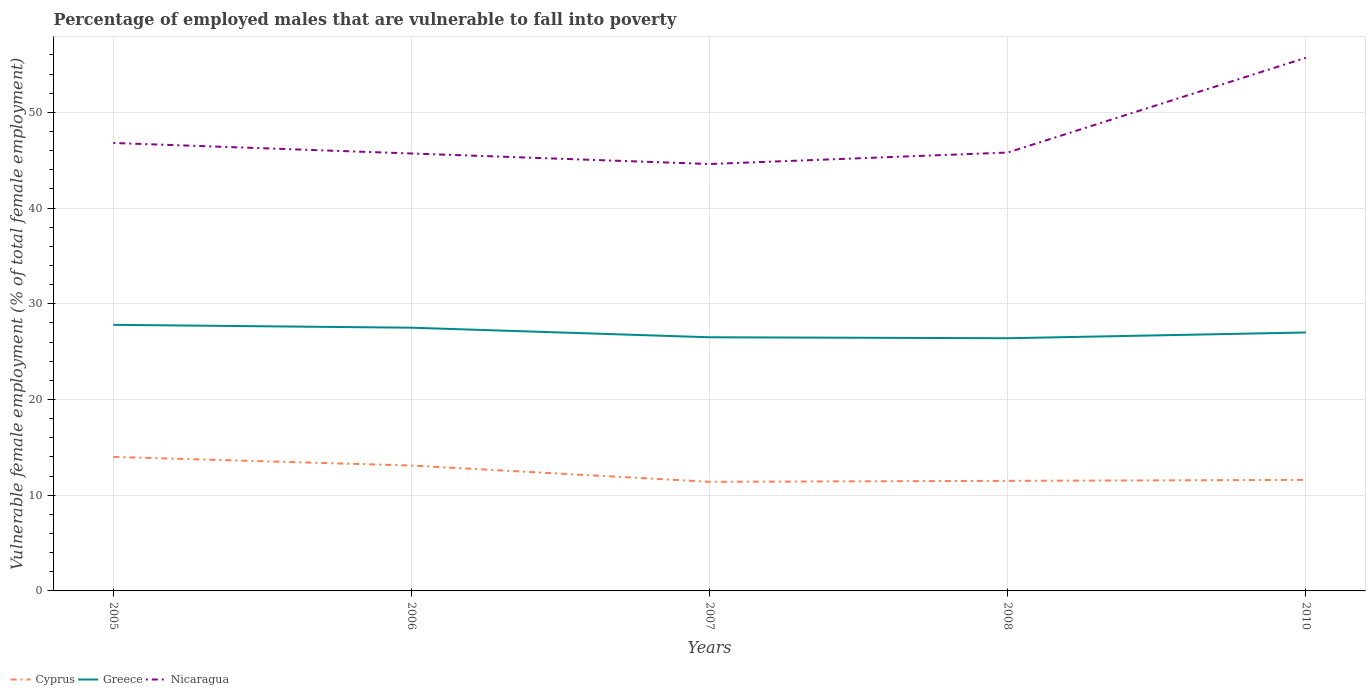How many different coloured lines are there?
Keep it short and to the point. 3. Does the line corresponding to Cyprus intersect with the line corresponding to Nicaragua?
Provide a short and direct response. No. Across all years, what is the maximum percentage of employed males who are vulnerable to fall into poverty in Nicaragua?
Offer a very short reply. 44.6. What is the total percentage of employed males who are vulnerable to fall into poverty in Nicaragua in the graph?
Your answer should be compact. -1.2. What is the difference between the highest and the second highest percentage of employed males who are vulnerable to fall into poverty in Nicaragua?
Give a very brief answer. 11.1. What is the difference between the highest and the lowest percentage of employed males who are vulnerable to fall into poverty in Greece?
Give a very brief answer. 2. How many lines are there?
Offer a very short reply. 3. Does the graph contain grids?
Offer a very short reply. Yes. Where does the legend appear in the graph?
Keep it short and to the point. Bottom left. How many legend labels are there?
Your response must be concise. 3. How are the legend labels stacked?
Give a very brief answer. Horizontal. What is the title of the graph?
Offer a terse response. Percentage of employed males that are vulnerable to fall into poverty. Does "Costa Rica" appear as one of the legend labels in the graph?
Offer a terse response. No. What is the label or title of the X-axis?
Your answer should be very brief. Years. What is the label or title of the Y-axis?
Make the answer very short. Vulnerable female employment (% of total female employment). What is the Vulnerable female employment (% of total female employment) of Greece in 2005?
Make the answer very short. 27.8. What is the Vulnerable female employment (% of total female employment) in Nicaragua in 2005?
Your answer should be very brief. 46.8. What is the Vulnerable female employment (% of total female employment) in Cyprus in 2006?
Offer a terse response. 13.1. What is the Vulnerable female employment (% of total female employment) in Nicaragua in 2006?
Your response must be concise. 45.7. What is the Vulnerable female employment (% of total female employment) of Cyprus in 2007?
Your response must be concise. 11.4. What is the Vulnerable female employment (% of total female employment) of Greece in 2007?
Your answer should be compact. 26.5. What is the Vulnerable female employment (% of total female employment) in Nicaragua in 2007?
Provide a short and direct response. 44.6. What is the Vulnerable female employment (% of total female employment) in Greece in 2008?
Offer a terse response. 26.4. What is the Vulnerable female employment (% of total female employment) in Nicaragua in 2008?
Your answer should be very brief. 45.8. What is the Vulnerable female employment (% of total female employment) of Cyprus in 2010?
Make the answer very short. 11.6. What is the Vulnerable female employment (% of total female employment) of Nicaragua in 2010?
Your response must be concise. 55.7. Across all years, what is the maximum Vulnerable female employment (% of total female employment) of Cyprus?
Provide a short and direct response. 14. Across all years, what is the maximum Vulnerable female employment (% of total female employment) of Greece?
Your answer should be compact. 27.8. Across all years, what is the maximum Vulnerable female employment (% of total female employment) of Nicaragua?
Make the answer very short. 55.7. Across all years, what is the minimum Vulnerable female employment (% of total female employment) in Cyprus?
Your answer should be very brief. 11.4. Across all years, what is the minimum Vulnerable female employment (% of total female employment) in Greece?
Keep it short and to the point. 26.4. Across all years, what is the minimum Vulnerable female employment (% of total female employment) of Nicaragua?
Offer a very short reply. 44.6. What is the total Vulnerable female employment (% of total female employment) of Cyprus in the graph?
Your response must be concise. 61.6. What is the total Vulnerable female employment (% of total female employment) in Greece in the graph?
Keep it short and to the point. 135.2. What is the total Vulnerable female employment (% of total female employment) in Nicaragua in the graph?
Offer a very short reply. 238.6. What is the difference between the Vulnerable female employment (% of total female employment) of Cyprus in 2005 and that in 2006?
Ensure brevity in your answer.  0.9. What is the difference between the Vulnerable female employment (% of total female employment) in Greece in 2005 and that in 2006?
Offer a very short reply. 0.3. What is the difference between the Vulnerable female employment (% of total female employment) of Nicaragua in 2005 and that in 2006?
Your answer should be compact. 1.1. What is the difference between the Vulnerable female employment (% of total female employment) in Greece in 2005 and that in 2007?
Provide a short and direct response. 1.3. What is the difference between the Vulnerable female employment (% of total female employment) of Nicaragua in 2005 and that in 2007?
Offer a terse response. 2.2. What is the difference between the Vulnerable female employment (% of total female employment) in Cyprus in 2005 and that in 2010?
Give a very brief answer. 2.4. What is the difference between the Vulnerable female employment (% of total female employment) in Greece in 2005 and that in 2010?
Provide a succinct answer. 0.8. What is the difference between the Vulnerable female employment (% of total female employment) in Cyprus in 2006 and that in 2007?
Provide a succinct answer. 1.7. What is the difference between the Vulnerable female employment (% of total female employment) in Greece in 2006 and that in 2008?
Ensure brevity in your answer.  1.1. What is the difference between the Vulnerable female employment (% of total female employment) in Cyprus in 2006 and that in 2010?
Offer a terse response. 1.5. What is the difference between the Vulnerable female employment (% of total female employment) in Nicaragua in 2006 and that in 2010?
Offer a terse response. -10. What is the difference between the Vulnerable female employment (% of total female employment) of Nicaragua in 2008 and that in 2010?
Offer a terse response. -9.9. What is the difference between the Vulnerable female employment (% of total female employment) in Cyprus in 2005 and the Vulnerable female employment (% of total female employment) in Nicaragua in 2006?
Give a very brief answer. -31.7. What is the difference between the Vulnerable female employment (% of total female employment) of Greece in 2005 and the Vulnerable female employment (% of total female employment) of Nicaragua in 2006?
Offer a terse response. -17.9. What is the difference between the Vulnerable female employment (% of total female employment) in Cyprus in 2005 and the Vulnerable female employment (% of total female employment) in Greece in 2007?
Provide a short and direct response. -12.5. What is the difference between the Vulnerable female employment (% of total female employment) in Cyprus in 2005 and the Vulnerable female employment (% of total female employment) in Nicaragua in 2007?
Your response must be concise. -30.6. What is the difference between the Vulnerable female employment (% of total female employment) of Greece in 2005 and the Vulnerable female employment (% of total female employment) of Nicaragua in 2007?
Give a very brief answer. -16.8. What is the difference between the Vulnerable female employment (% of total female employment) in Cyprus in 2005 and the Vulnerable female employment (% of total female employment) in Nicaragua in 2008?
Provide a short and direct response. -31.8. What is the difference between the Vulnerable female employment (% of total female employment) in Greece in 2005 and the Vulnerable female employment (% of total female employment) in Nicaragua in 2008?
Your response must be concise. -18. What is the difference between the Vulnerable female employment (% of total female employment) of Cyprus in 2005 and the Vulnerable female employment (% of total female employment) of Nicaragua in 2010?
Offer a terse response. -41.7. What is the difference between the Vulnerable female employment (% of total female employment) in Greece in 2005 and the Vulnerable female employment (% of total female employment) in Nicaragua in 2010?
Offer a very short reply. -27.9. What is the difference between the Vulnerable female employment (% of total female employment) of Cyprus in 2006 and the Vulnerable female employment (% of total female employment) of Nicaragua in 2007?
Provide a succinct answer. -31.5. What is the difference between the Vulnerable female employment (% of total female employment) in Greece in 2006 and the Vulnerable female employment (% of total female employment) in Nicaragua in 2007?
Your response must be concise. -17.1. What is the difference between the Vulnerable female employment (% of total female employment) in Cyprus in 2006 and the Vulnerable female employment (% of total female employment) in Greece in 2008?
Provide a short and direct response. -13.3. What is the difference between the Vulnerable female employment (% of total female employment) in Cyprus in 2006 and the Vulnerable female employment (% of total female employment) in Nicaragua in 2008?
Provide a short and direct response. -32.7. What is the difference between the Vulnerable female employment (% of total female employment) of Greece in 2006 and the Vulnerable female employment (% of total female employment) of Nicaragua in 2008?
Make the answer very short. -18.3. What is the difference between the Vulnerable female employment (% of total female employment) in Cyprus in 2006 and the Vulnerable female employment (% of total female employment) in Nicaragua in 2010?
Offer a very short reply. -42.6. What is the difference between the Vulnerable female employment (% of total female employment) in Greece in 2006 and the Vulnerable female employment (% of total female employment) in Nicaragua in 2010?
Offer a terse response. -28.2. What is the difference between the Vulnerable female employment (% of total female employment) in Cyprus in 2007 and the Vulnerable female employment (% of total female employment) in Greece in 2008?
Your answer should be very brief. -15. What is the difference between the Vulnerable female employment (% of total female employment) of Cyprus in 2007 and the Vulnerable female employment (% of total female employment) of Nicaragua in 2008?
Make the answer very short. -34.4. What is the difference between the Vulnerable female employment (% of total female employment) in Greece in 2007 and the Vulnerable female employment (% of total female employment) in Nicaragua in 2008?
Ensure brevity in your answer.  -19.3. What is the difference between the Vulnerable female employment (% of total female employment) in Cyprus in 2007 and the Vulnerable female employment (% of total female employment) in Greece in 2010?
Your response must be concise. -15.6. What is the difference between the Vulnerable female employment (% of total female employment) of Cyprus in 2007 and the Vulnerable female employment (% of total female employment) of Nicaragua in 2010?
Offer a very short reply. -44.3. What is the difference between the Vulnerable female employment (% of total female employment) of Greece in 2007 and the Vulnerable female employment (% of total female employment) of Nicaragua in 2010?
Offer a terse response. -29.2. What is the difference between the Vulnerable female employment (% of total female employment) of Cyprus in 2008 and the Vulnerable female employment (% of total female employment) of Greece in 2010?
Your answer should be very brief. -15.5. What is the difference between the Vulnerable female employment (% of total female employment) of Cyprus in 2008 and the Vulnerable female employment (% of total female employment) of Nicaragua in 2010?
Your answer should be compact. -44.2. What is the difference between the Vulnerable female employment (% of total female employment) of Greece in 2008 and the Vulnerable female employment (% of total female employment) of Nicaragua in 2010?
Your response must be concise. -29.3. What is the average Vulnerable female employment (% of total female employment) in Cyprus per year?
Give a very brief answer. 12.32. What is the average Vulnerable female employment (% of total female employment) of Greece per year?
Keep it short and to the point. 27.04. What is the average Vulnerable female employment (% of total female employment) of Nicaragua per year?
Offer a very short reply. 47.72. In the year 2005, what is the difference between the Vulnerable female employment (% of total female employment) of Cyprus and Vulnerable female employment (% of total female employment) of Nicaragua?
Your response must be concise. -32.8. In the year 2005, what is the difference between the Vulnerable female employment (% of total female employment) of Greece and Vulnerable female employment (% of total female employment) of Nicaragua?
Ensure brevity in your answer.  -19. In the year 2006, what is the difference between the Vulnerable female employment (% of total female employment) of Cyprus and Vulnerable female employment (% of total female employment) of Greece?
Give a very brief answer. -14.4. In the year 2006, what is the difference between the Vulnerable female employment (% of total female employment) of Cyprus and Vulnerable female employment (% of total female employment) of Nicaragua?
Offer a terse response. -32.6. In the year 2006, what is the difference between the Vulnerable female employment (% of total female employment) of Greece and Vulnerable female employment (% of total female employment) of Nicaragua?
Offer a terse response. -18.2. In the year 2007, what is the difference between the Vulnerable female employment (% of total female employment) of Cyprus and Vulnerable female employment (% of total female employment) of Greece?
Give a very brief answer. -15.1. In the year 2007, what is the difference between the Vulnerable female employment (% of total female employment) of Cyprus and Vulnerable female employment (% of total female employment) of Nicaragua?
Your answer should be compact. -33.2. In the year 2007, what is the difference between the Vulnerable female employment (% of total female employment) of Greece and Vulnerable female employment (% of total female employment) of Nicaragua?
Your response must be concise. -18.1. In the year 2008, what is the difference between the Vulnerable female employment (% of total female employment) in Cyprus and Vulnerable female employment (% of total female employment) in Greece?
Keep it short and to the point. -14.9. In the year 2008, what is the difference between the Vulnerable female employment (% of total female employment) of Cyprus and Vulnerable female employment (% of total female employment) of Nicaragua?
Ensure brevity in your answer.  -34.3. In the year 2008, what is the difference between the Vulnerable female employment (% of total female employment) in Greece and Vulnerable female employment (% of total female employment) in Nicaragua?
Your answer should be compact. -19.4. In the year 2010, what is the difference between the Vulnerable female employment (% of total female employment) in Cyprus and Vulnerable female employment (% of total female employment) in Greece?
Offer a terse response. -15.4. In the year 2010, what is the difference between the Vulnerable female employment (% of total female employment) of Cyprus and Vulnerable female employment (% of total female employment) of Nicaragua?
Your answer should be very brief. -44.1. In the year 2010, what is the difference between the Vulnerable female employment (% of total female employment) of Greece and Vulnerable female employment (% of total female employment) of Nicaragua?
Your answer should be compact. -28.7. What is the ratio of the Vulnerable female employment (% of total female employment) of Cyprus in 2005 to that in 2006?
Offer a terse response. 1.07. What is the ratio of the Vulnerable female employment (% of total female employment) of Greece in 2005 to that in 2006?
Your answer should be compact. 1.01. What is the ratio of the Vulnerable female employment (% of total female employment) of Nicaragua in 2005 to that in 2006?
Offer a terse response. 1.02. What is the ratio of the Vulnerable female employment (% of total female employment) in Cyprus in 2005 to that in 2007?
Ensure brevity in your answer.  1.23. What is the ratio of the Vulnerable female employment (% of total female employment) in Greece in 2005 to that in 2007?
Provide a succinct answer. 1.05. What is the ratio of the Vulnerable female employment (% of total female employment) of Nicaragua in 2005 to that in 2007?
Make the answer very short. 1.05. What is the ratio of the Vulnerable female employment (% of total female employment) in Cyprus in 2005 to that in 2008?
Make the answer very short. 1.22. What is the ratio of the Vulnerable female employment (% of total female employment) of Greece in 2005 to that in 2008?
Provide a short and direct response. 1.05. What is the ratio of the Vulnerable female employment (% of total female employment) of Nicaragua in 2005 to that in 2008?
Provide a short and direct response. 1.02. What is the ratio of the Vulnerable female employment (% of total female employment) of Cyprus in 2005 to that in 2010?
Offer a terse response. 1.21. What is the ratio of the Vulnerable female employment (% of total female employment) in Greece in 2005 to that in 2010?
Provide a succinct answer. 1.03. What is the ratio of the Vulnerable female employment (% of total female employment) of Nicaragua in 2005 to that in 2010?
Provide a succinct answer. 0.84. What is the ratio of the Vulnerable female employment (% of total female employment) in Cyprus in 2006 to that in 2007?
Make the answer very short. 1.15. What is the ratio of the Vulnerable female employment (% of total female employment) in Greece in 2006 to that in 2007?
Make the answer very short. 1.04. What is the ratio of the Vulnerable female employment (% of total female employment) in Nicaragua in 2006 to that in 2007?
Provide a succinct answer. 1.02. What is the ratio of the Vulnerable female employment (% of total female employment) of Cyprus in 2006 to that in 2008?
Offer a very short reply. 1.14. What is the ratio of the Vulnerable female employment (% of total female employment) of Greece in 2006 to that in 2008?
Your response must be concise. 1.04. What is the ratio of the Vulnerable female employment (% of total female employment) of Nicaragua in 2006 to that in 2008?
Provide a succinct answer. 1. What is the ratio of the Vulnerable female employment (% of total female employment) in Cyprus in 2006 to that in 2010?
Keep it short and to the point. 1.13. What is the ratio of the Vulnerable female employment (% of total female employment) in Greece in 2006 to that in 2010?
Ensure brevity in your answer.  1.02. What is the ratio of the Vulnerable female employment (% of total female employment) of Nicaragua in 2006 to that in 2010?
Keep it short and to the point. 0.82. What is the ratio of the Vulnerable female employment (% of total female employment) of Nicaragua in 2007 to that in 2008?
Your response must be concise. 0.97. What is the ratio of the Vulnerable female employment (% of total female employment) in Cyprus in 2007 to that in 2010?
Provide a succinct answer. 0.98. What is the ratio of the Vulnerable female employment (% of total female employment) in Greece in 2007 to that in 2010?
Your response must be concise. 0.98. What is the ratio of the Vulnerable female employment (% of total female employment) of Nicaragua in 2007 to that in 2010?
Your answer should be compact. 0.8. What is the ratio of the Vulnerable female employment (% of total female employment) of Greece in 2008 to that in 2010?
Offer a terse response. 0.98. What is the ratio of the Vulnerable female employment (% of total female employment) in Nicaragua in 2008 to that in 2010?
Your answer should be compact. 0.82. What is the difference between the highest and the second highest Vulnerable female employment (% of total female employment) in Cyprus?
Offer a terse response. 0.9. What is the difference between the highest and the second highest Vulnerable female employment (% of total female employment) of Nicaragua?
Ensure brevity in your answer.  8.9. What is the difference between the highest and the lowest Vulnerable female employment (% of total female employment) of Nicaragua?
Offer a very short reply. 11.1. 